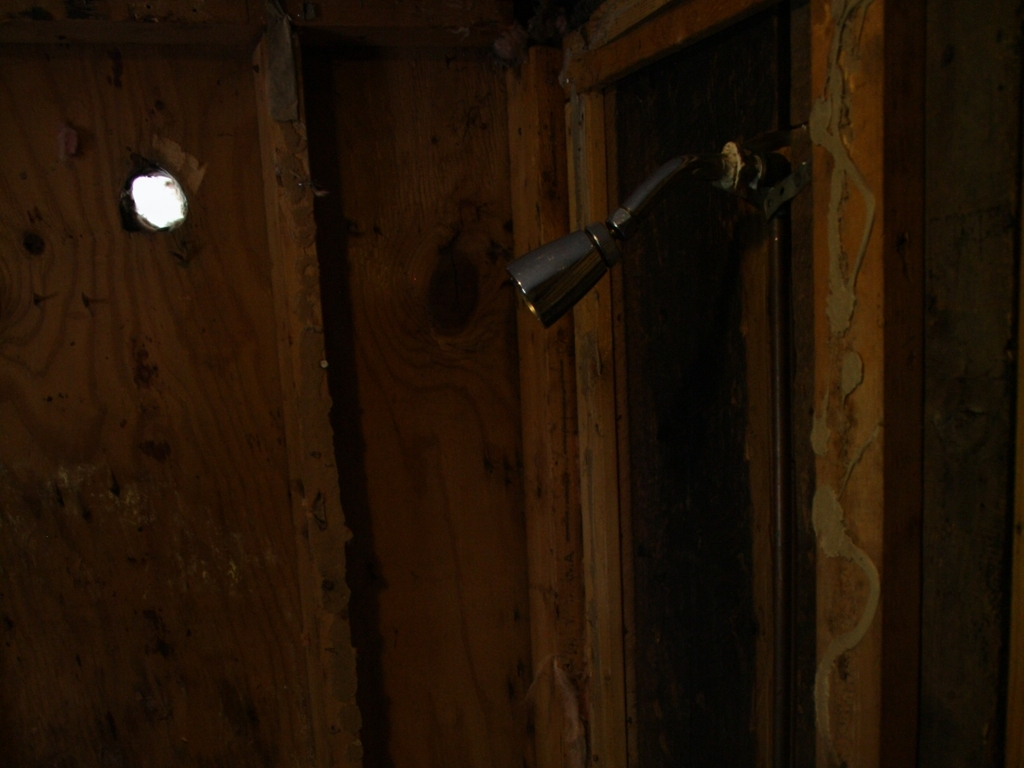What does the single light source tell us about the atmosphere of the place? The solitary beam of light punctuating the darkness contributes to an atmosphere of desolation and mystery. It creates a dramatic effect that could evoke feelings of curiosity or unease, hinting at a hidden narrative or the passage of time within these walls. 